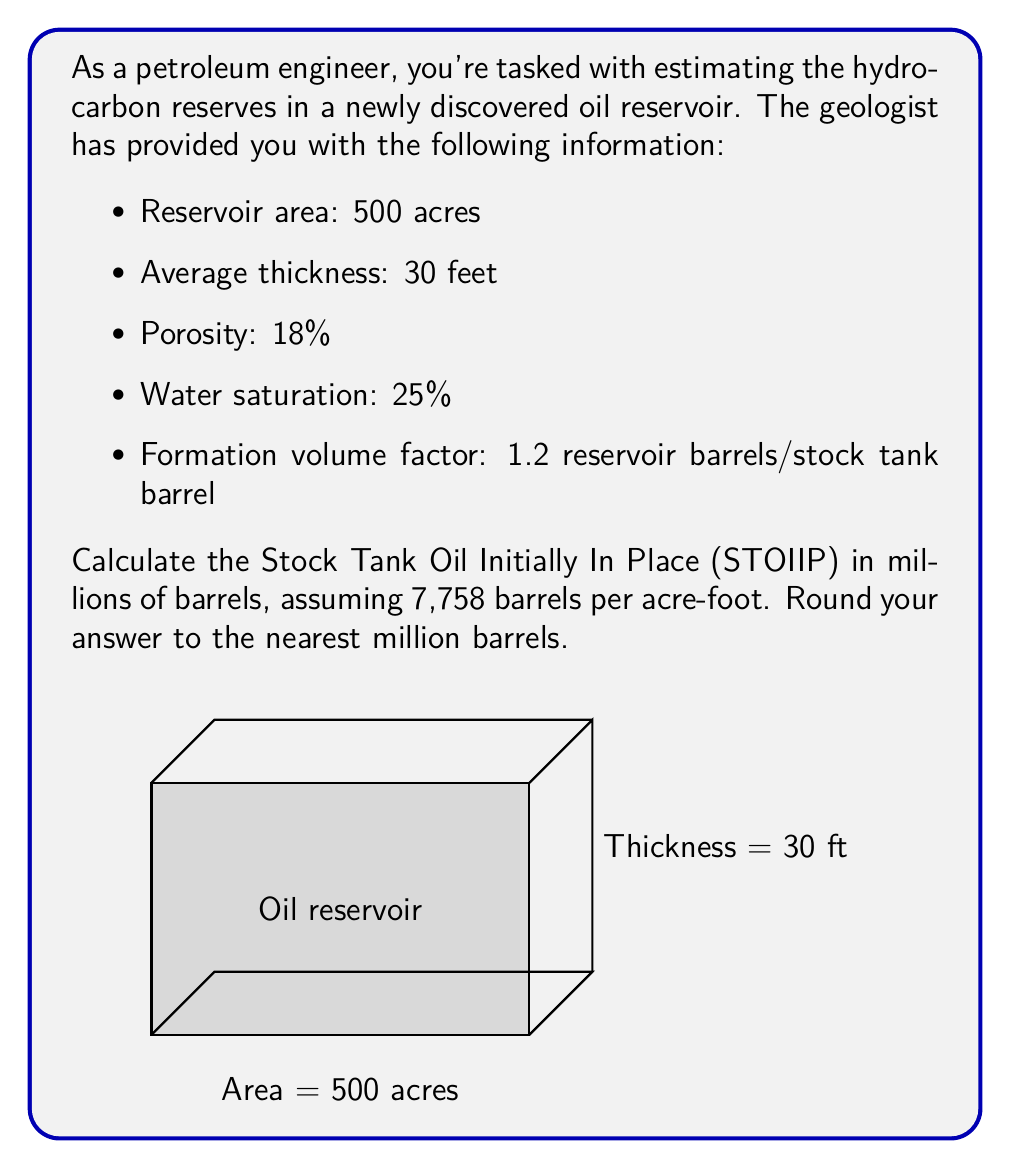Help me with this question. Let's break this down step-by-step:

1) First, we need to calculate the Gross Rock Volume (GRV):
   $GRV = Area \times Thickness$
   $GRV = 500 \text{ acres} \times 30 \text{ feet} = 15,000 \text{ acre-feet}$

2) Next, we calculate the Pore Volume (PV):
   $PV = GRV \times Porosity$
   $PV = 15,000 \times 0.18 = 2,700 \text{ acre-feet}$

3) Now, we calculate the Hydrocarbon Pore Volume (HCPV):
   $HCPV = PV \times (1 - Water Saturation)$
   $HCPV = 2,700 \times (1 - 0.25) = 2,025 \text{ acre-feet}$

4) Convert HCPV to barrels:
   $HCPV_{barrels} = HCPV \times 7,758 \text{ barrels/acre-foot}$
   $HCPV_{barrels} = 2,025 \times 7,758 = 15,709,950 \text{ barrels}$

5) Finally, calculate STOIIP by dividing by the Formation Volume Factor:
   $STOIIP = \frac{HCPV_{barrels}}{FVF}$
   $STOIIP = \frac{15,709,950}{1.2} = 13,091,625 \text{ barrels}$

6) Convert to millions of barrels and round:
   $STOIIP = 13.09 \text{ million barrels} \approx 13 \text{ million barrels}$
Answer: 13 million barrels 